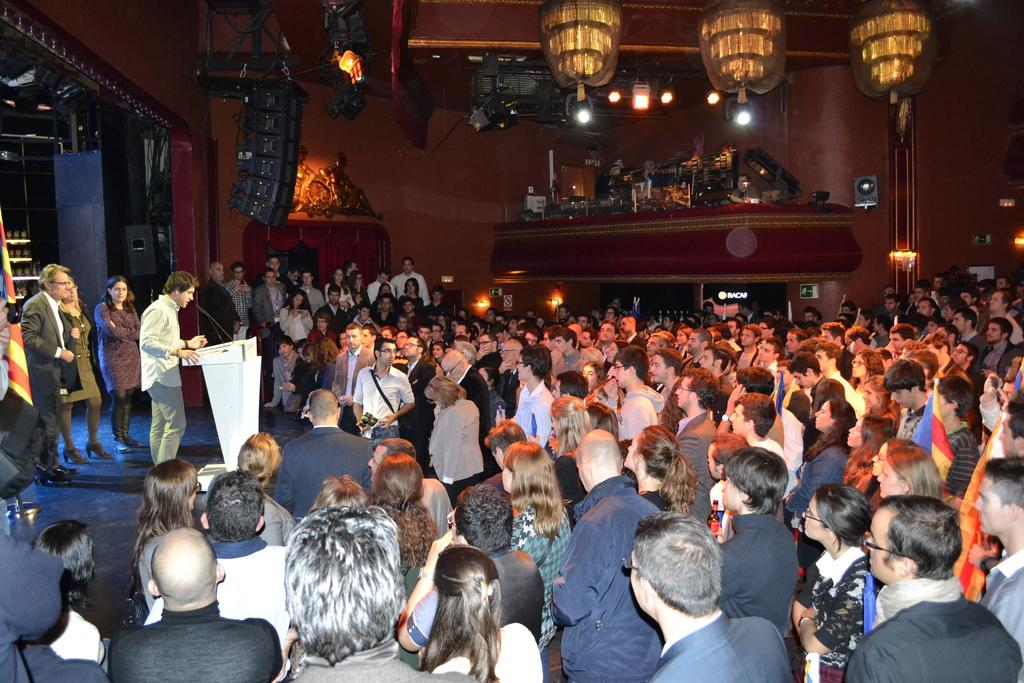How many people are in the image? There are many people in the image. What is one person doing in the image? One person is standing and talking in front of a microphone. What can be seen in the hall where the people are gathered? There are objects placed in the hall. What is the brother of the person talking in front of the microphone doing in the image? There is no mention of a brother in the image, so it is not possible to answer that question. 